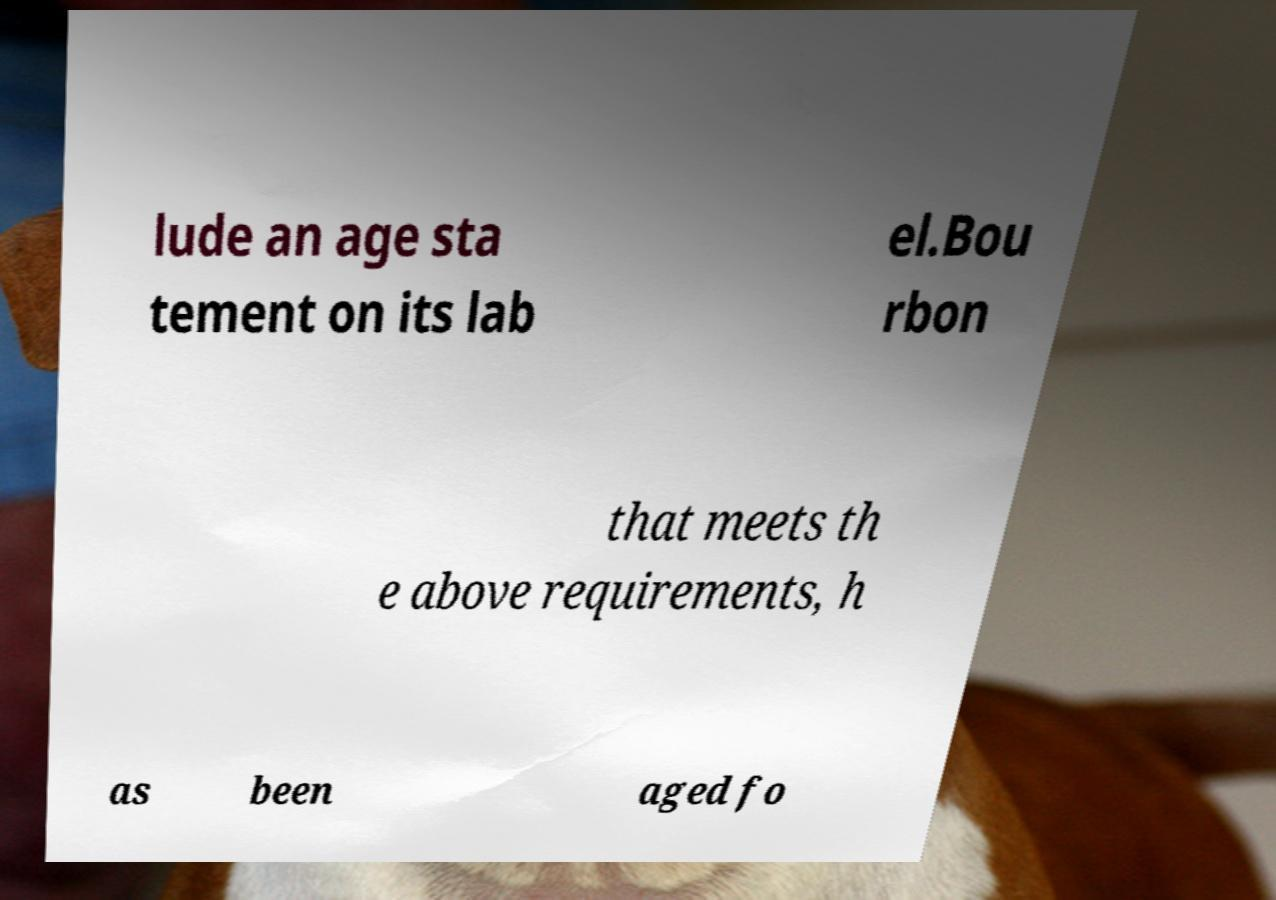Please read and relay the text visible in this image. What does it say? lude an age sta tement on its lab el.Bou rbon that meets th e above requirements, h as been aged fo 